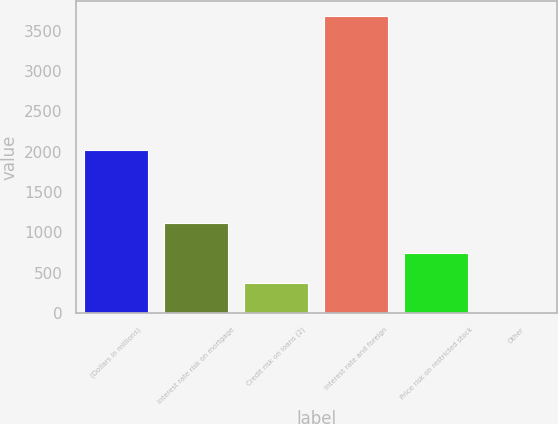Convert chart. <chart><loc_0><loc_0><loc_500><loc_500><bar_chart><fcel>(Dollars in millions)<fcel>Interest rate risk on mortgage<fcel>Credit risk on loans (2)<fcel>Interest rate and foreign<fcel>Price risk on restricted stock<fcel>Other<nl><fcel>2014<fcel>1111.2<fcel>376.4<fcel>3683<fcel>743.8<fcel>9<nl></chart> 